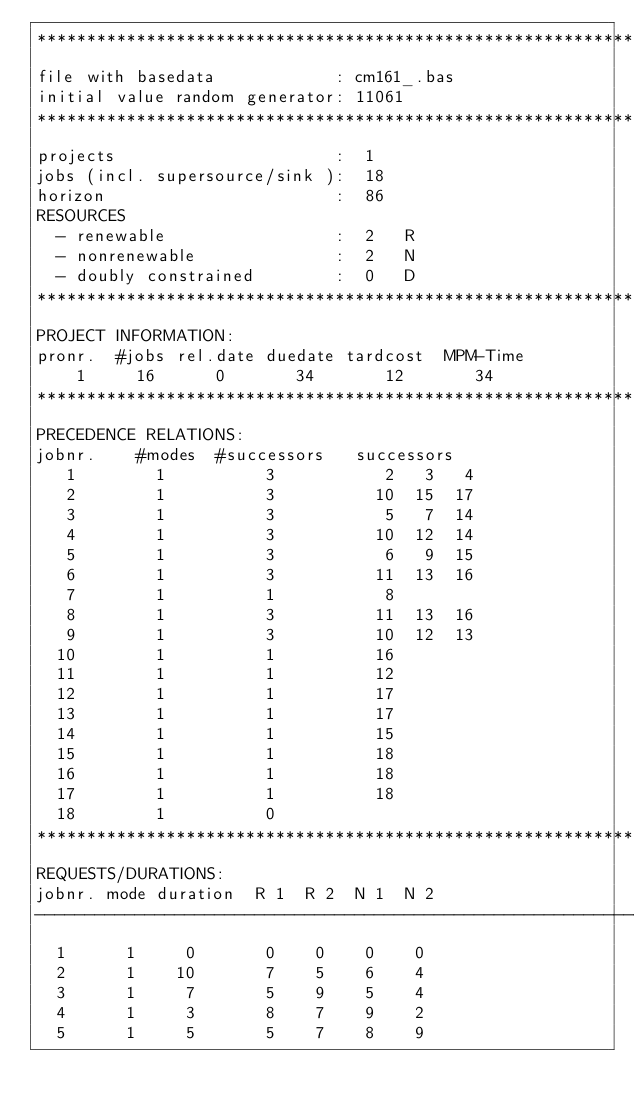Convert code to text. <code><loc_0><loc_0><loc_500><loc_500><_ObjectiveC_>************************************************************************
file with basedata            : cm161_.bas
initial value random generator: 11061
************************************************************************
projects                      :  1
jobs (incl. supersource/sink ):  18
horizon                       :  86
RESOURCES
  - renewable                 :  2   R
  - nonrenewable              :  2   N
  - doubly constrained        :  0   D
************************************************************************
PROJECT INFORMATION:
pronr.  #jobs rel.date duedate tardcost  MPM-Time
    1     16      0       34       12       34
************************************************************************
PRECEDENCE RELATIONS:
jobnr.    #modes  #successors   successors
   1        1          3           2   3   4
   2        1          3          10  15  17
   3        1          3           5   7  14
   4        1          3          10  12  14
   5        1          3           6   9  15
   6        1          3          11  13  16
   7        1          1           8
   8        1          3          11  13  16
   9        1          3          10  12  13
  10        1          1          16
  11        1          1          12
  12        1          1          17
  13        1          1          17
  14        1          1          15
  15        1          1          18
  16        1          1          18
  17        1          1          18
  18        1          0        
************************************************************************
REQUESTS/DURATIONS:
jobnr. mode duration  R 1  R 2  N 1  N 2
------------------------------------------------------------------------
  1      1     0       0    0    0    0
  2      1    10       7    5    6    4
  3      1     7       5    9    5    4
  4      1     3       8    7    9    2
  5      1     5       5    7    8    9</code> 